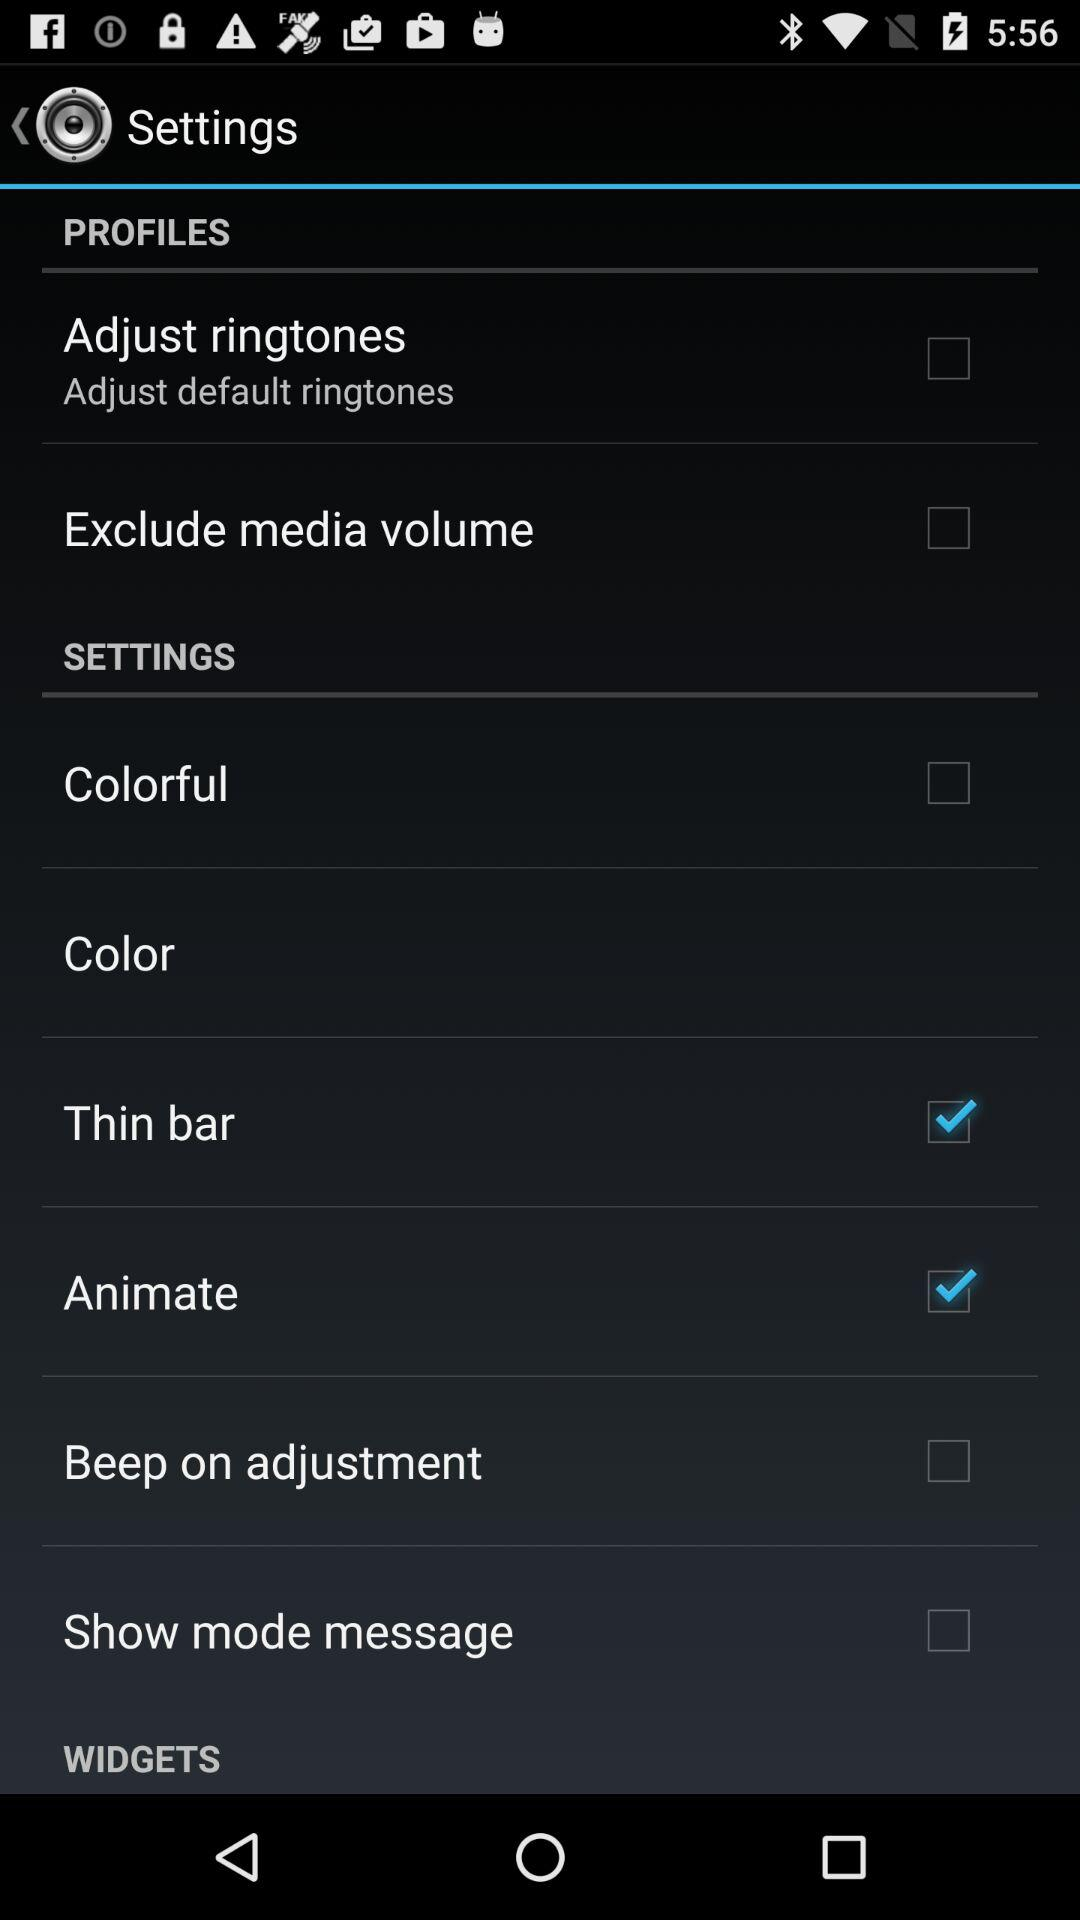What is the status of "Color"?
When the provided information is insufficient, respond with <no answer>. <no answer> 